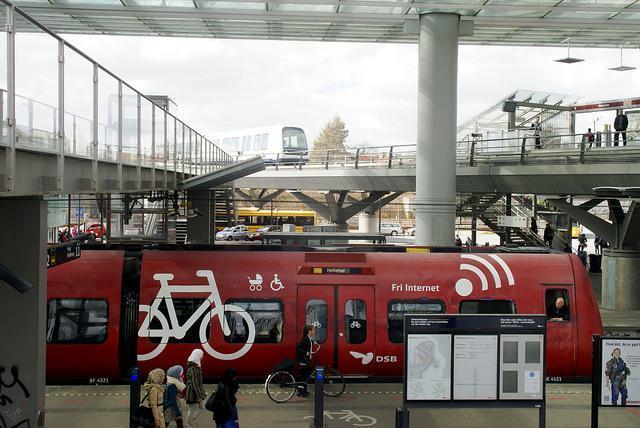How many trains are visible?
Give a very brief answer. 2. How many cupcakes have an elephant on them?
Give a very brief answer. 0. 